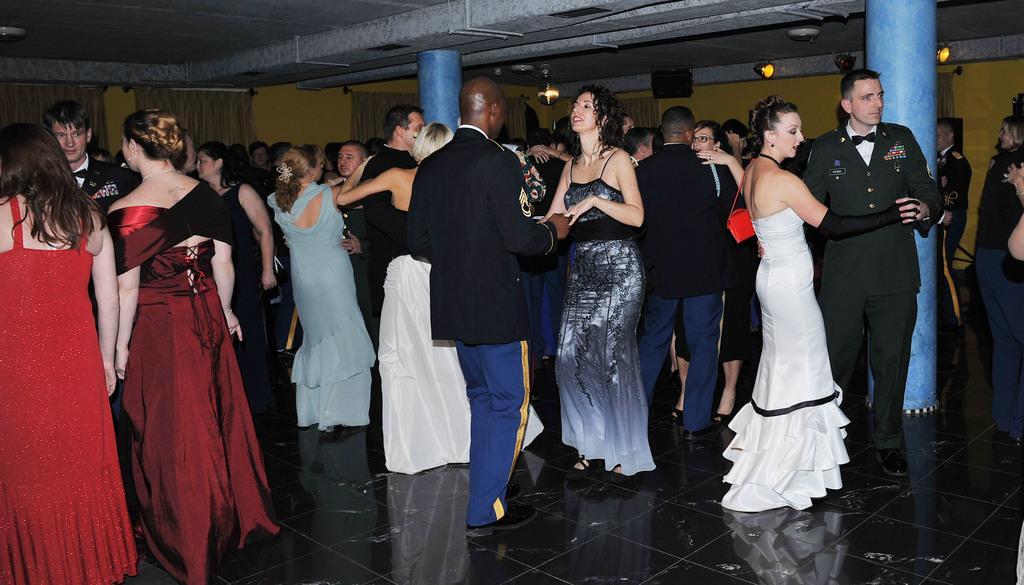In one or two sentences, can you explain what this image depicts? In the picture I can see few persons dancing and there are few lights and speakers attached to the wall in the background. 